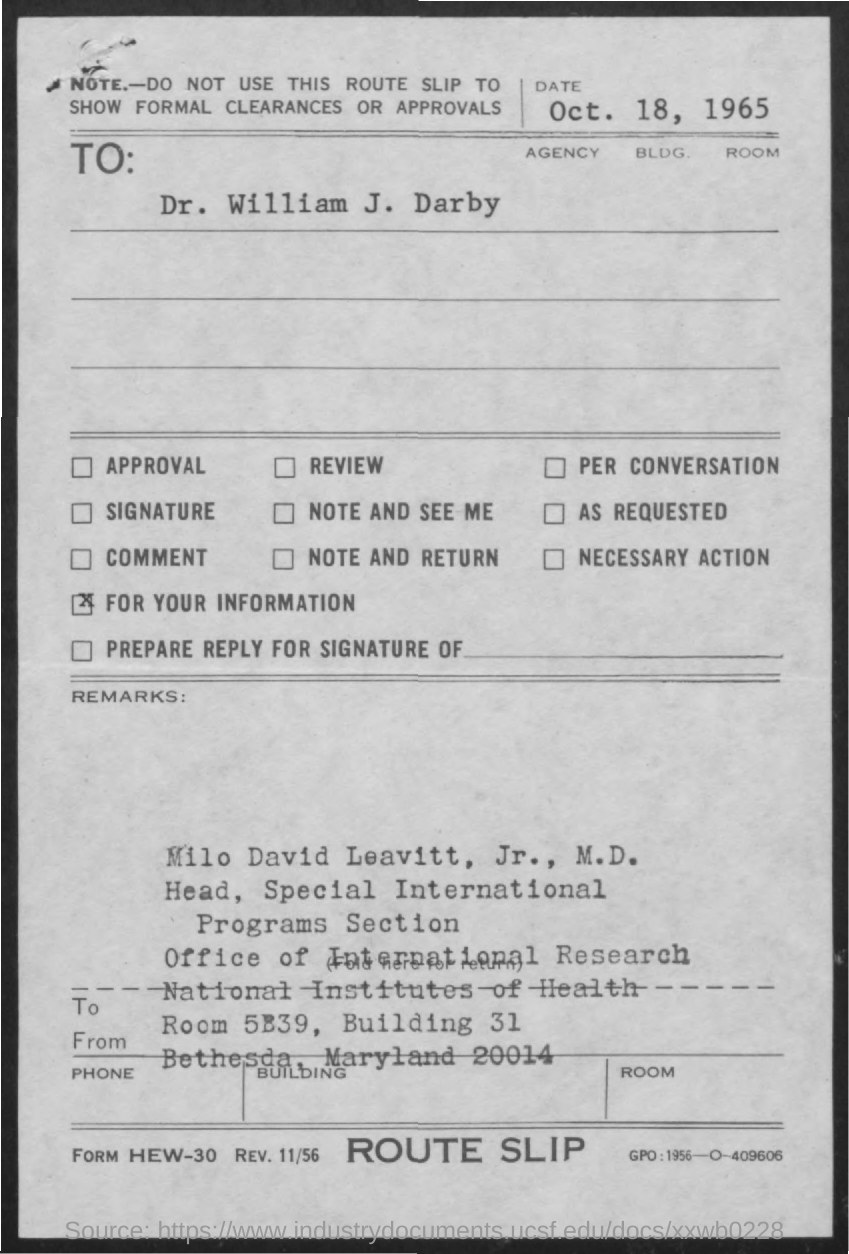What is the date on the document?
Your answer should be compact. Oct. 18, 1965. To Whom is this letter addressed to?
Offer a very short reply. DR. WILLIAM J. DARBY. 